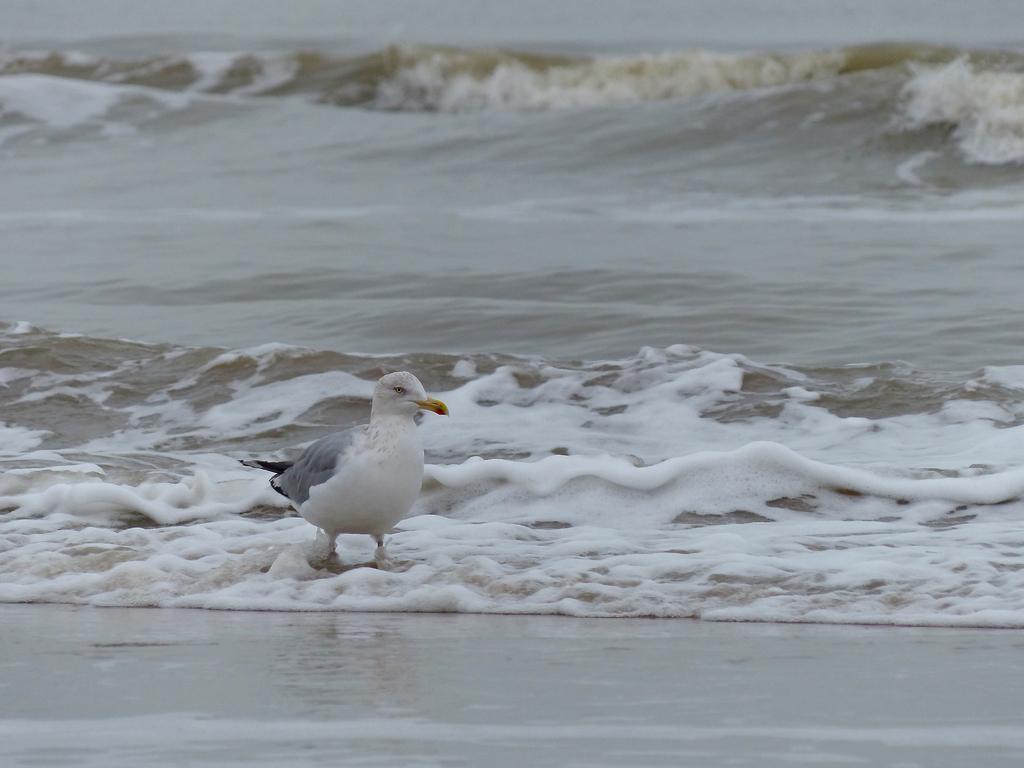Could you give a brief overview of what you see in this image? In the center of the image we can see bird on the water. At the bottom there is sand. 